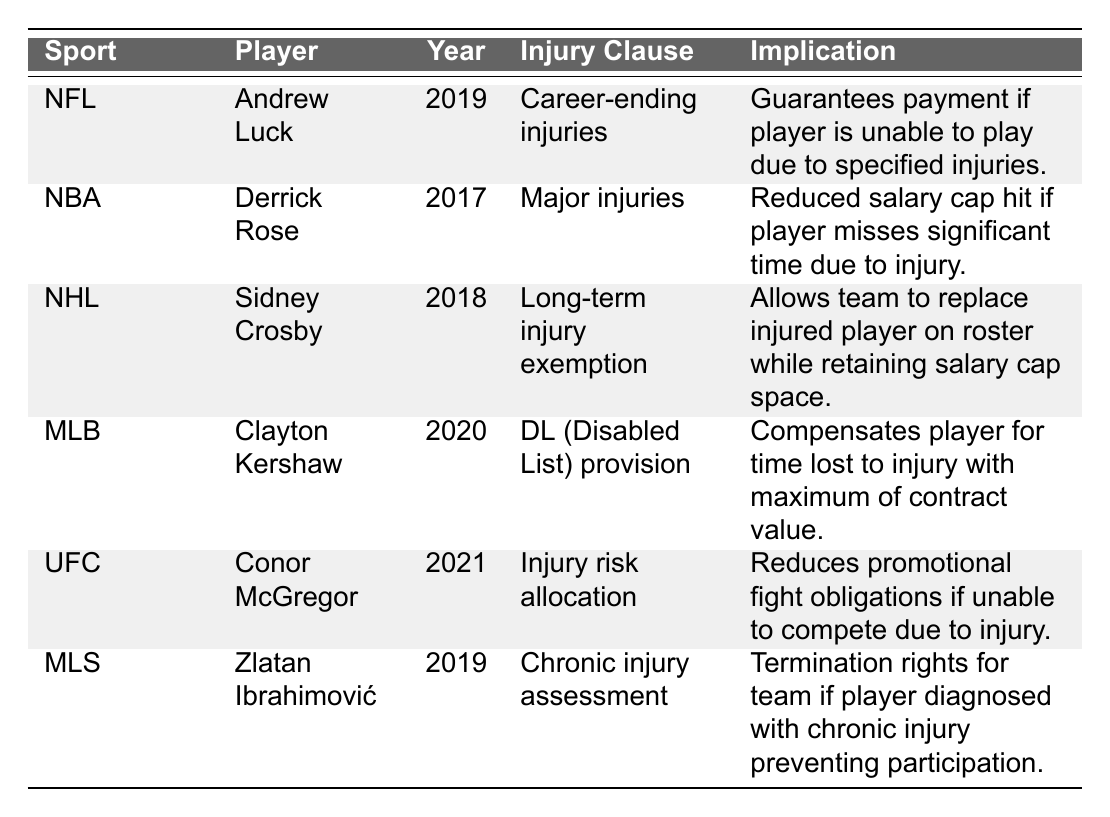What injury clause is associated with Andrew Luck? The table lists the injury clause for Andrew Luck under the NFL in 2019 as "Career-ending injuries."
Answer: Career-ending injuries Which player has an injury clause that allows a team to replace them on the roster? Sidney Crosby, playing in the NHL in 2018, has an injury clause termed "Long-term injury exemption," which permits the team to replace him on the roster.
Answer: Sidney Crosby Does Derrick Rose have an injury clause that reduces the salary cap hit? Yes, Derrick Rose has an injury clause for "Major injuries" that results in a reduced salary cap hit if he misses significant playing time due to injury.
Answer: Yes Which sports player has a contract year in 2020? Clayton Kershaw, an MLB player, has his contract year listed as 2020 in the table.
Answer: Clayton Kershaw What does the injury clause of Conor McGregor entail? Conor McGregor's injury clause, listed as "Injury risk allocation," means it reduces promotional fight obligations if he cannot compete due to injury.
Answer: Reduces promotional fight obligations For which player does the injury clause terminate the team's rights if diagnosed with a chronic injury? Zlatan Ibrahimović has an injury clause termed "Chronic injury assessment," which gives the team termination rights if he is diagnosed with a chronic injury that prevents his participation.
Answer: Zlatan Ibrahimović What is the implication of the "DL (Disabled List) provision" for Clayton Kershaw? The implication of Clayton Kershaw's "DL (Disabled List) provision" is that it compensates him for the time lost to injury up to the maximum value of his contract.
Answer: Compensates for time lost to injury Who has the earliest contract year listed in the table? Derrick Rose has the earliest contract year listed in the table, which is 2017.
Answer: Derrick Rose Which player does not have a specified injury clause relating to long-term injuries? Andrew Luck's injury clause is specifically about career-ending injuries, which does not involve long-term injuries directly.
Answer: Andrew Luck If we compare the implications of the injury clauses between NFL and MLS players, which one has termination rights for chronic injury? The implication comparison shows that Zlatan Ibrahimović from MLS has termination rights if diagnosed with a chronic injury, whereas Andrew Luck ensures payment for career-ending injuries.
Answer: Zlatan Ibrahimović 